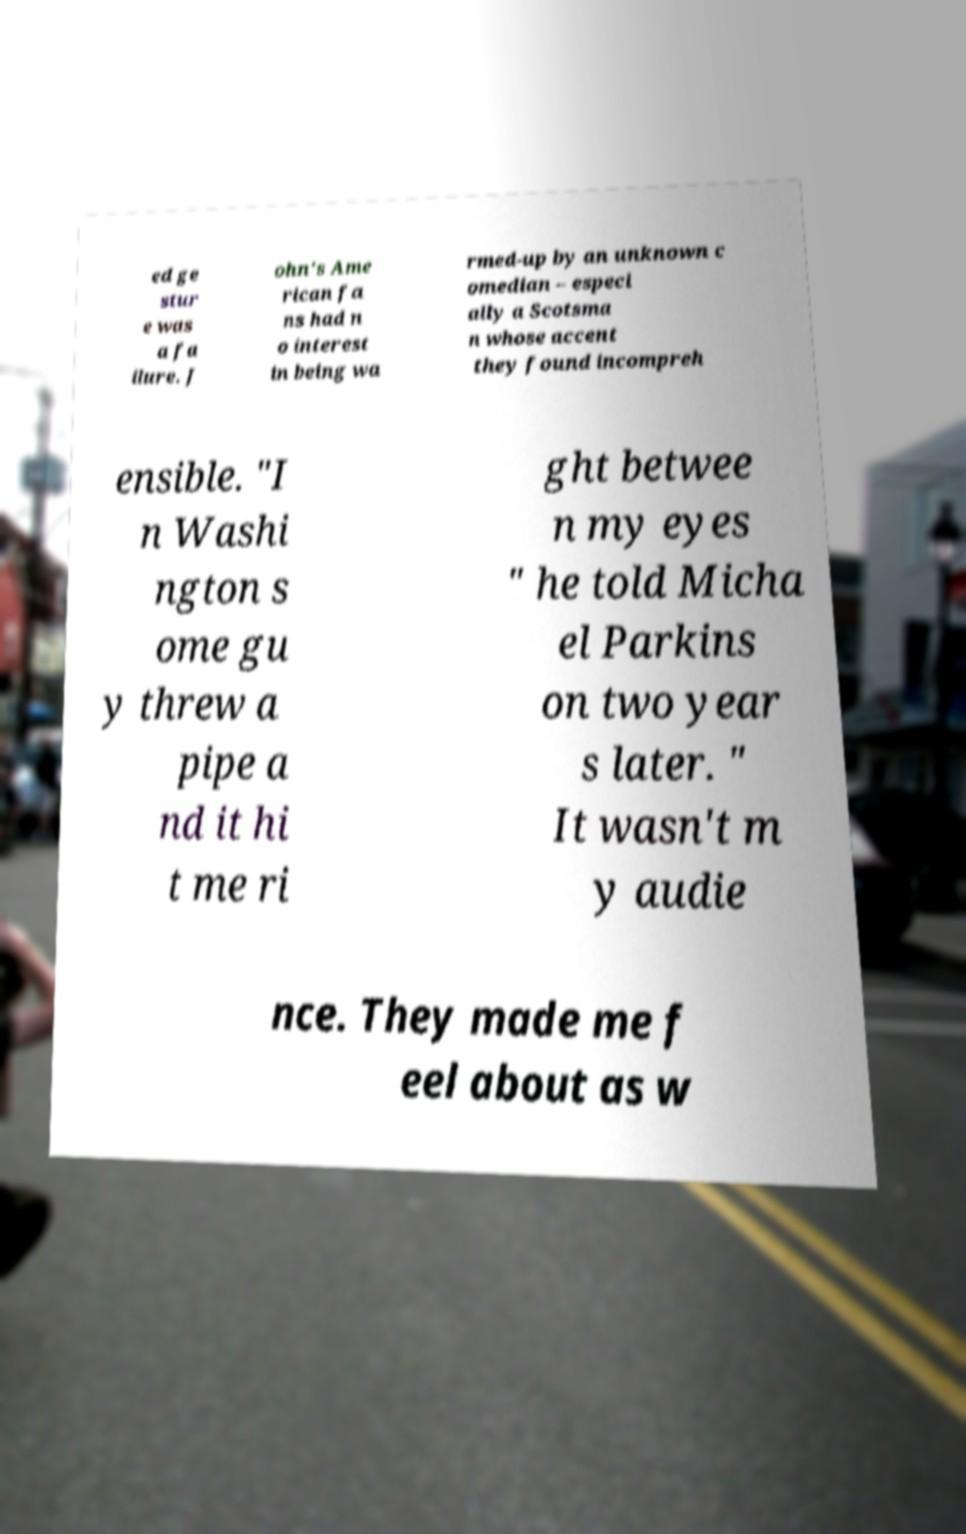Could you assist in decoding the text presented in this image and type it out clearly? ed ge stur e was a fa ilure. J ohn's Ame rican fa ns had n o interest in being wa rmed-up by an unknown c omedian – especi ally a Scotsma n whose accent they found incompreh ensible. "I n Washi ngton s ome gu y threw a pipe a nd it hi t me ri ght betwee n my eyes " he told Micha el Parkins on two year s later. " It wasn't m y audie nce. They made me f eel about as w 